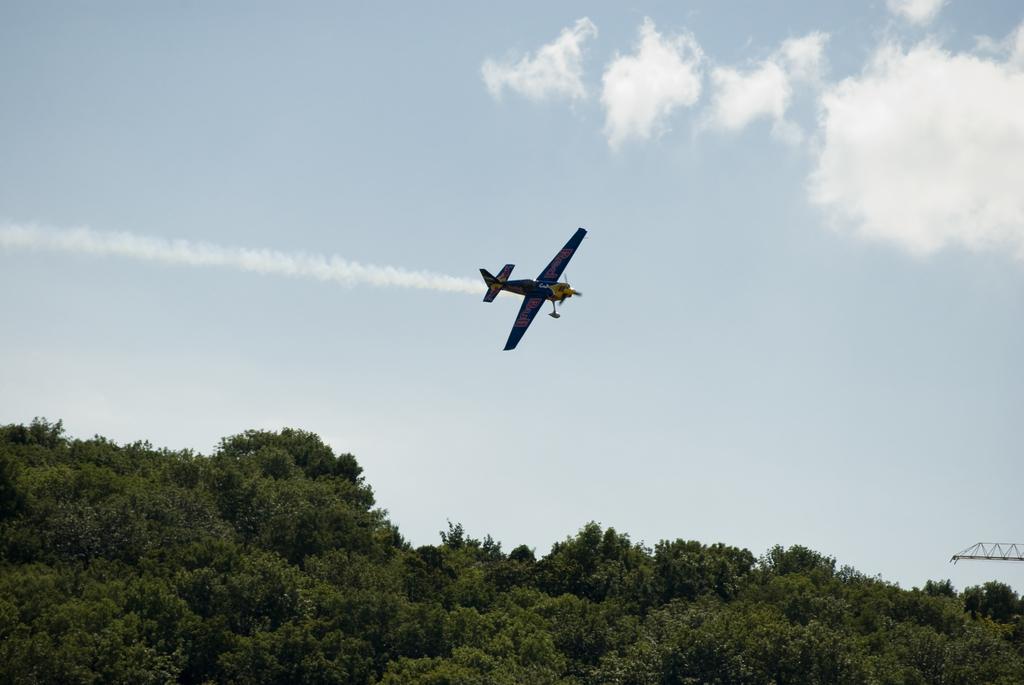In one or two sentences, can you explain what this image depicts? In this picture we can see plane which is flying. On the bottom we can see trees on the mountain. On the bottom right corner there is a crane. On the top we can see sky and clouds. Here we can see smoke which is coming from the plane. 